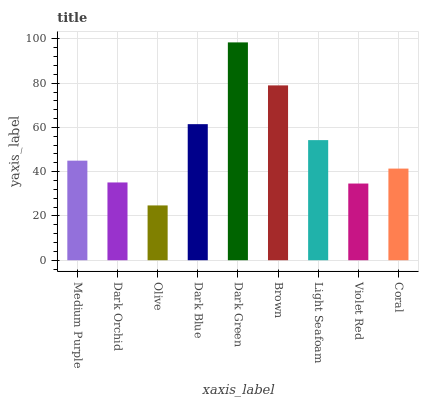Is Dark Orchid the minimum?
Answer yes or no. No. Is Dark Orchid the maximum?
Answer yes or no. No. Is Medium Purple greater than Dark Orchid?
Answer yes or no. Yes. Is Dark Orchid less than Medium Purple?
Answer yes or no. Yes. Is Dark Orchid greater than Medium Purple?
Answer yes or no. No. Is Medium Purple less than Dark Orchid?
Answer yes or no. No. Is Medium Purple the high median?
Answer yes or no. Yes. Is Medium Purple the low median?
Answer yes or no. Yes. Is Violet Red the high median?
Answer yes or no. No. Is Dark Green the low median?
Answer yes or no. No. 